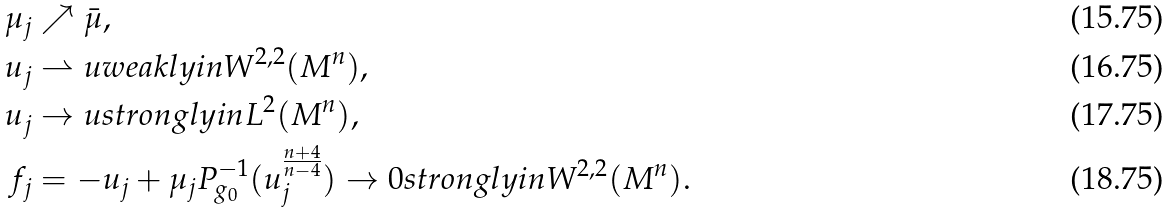<formula> <loc_0><loc_0><loc_500><loc_500>\mu _ { j } & \nearrow \bar { \mu } , \\ u _ { j } & \rightharpoonup u w e a k l y i n W ^ { 2 , 2 } ( M ^ { n } ) , \\ u _ { j } & \rightarrow u s t r o n g l y i n L ^ { 2 } ( M ^ { n } ) , \\ f _ { j } & = - u _ { j } + \mu _ { j } P _ { g _ { 0 } } ^ { - 1 } ( u _ { j } ^ { \frac { n + 4 } { n - 4 } } ) \rightarrow 0 s t r o n g l y i n W ^ { 2 , 2 } ( M ^ { n } ) .</formula> 